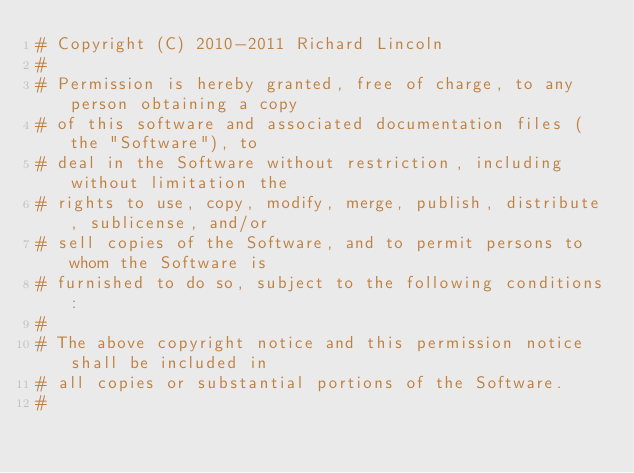Convert code to text. <code><loc_0><loc_0><loc_500><loc_500><_Python_># Copyright (C) 2010-2011 Richard Lincoln
#
# Permission is hereby granted, free of charge, to any person obtaining a copy
# of this software and associated documentation files (the "Software"), to
# deal in the Software without restriction, including without limitation the
# rights to use, copy, modify, merge, publish, distribute, sublicense, and/or
# sell copies of the Software, and to permit persons to whom the Software is
# furnished to do so, subject to the following conditions:
#
# The above copyright notice and this permission notice shall be included in
# all copies or substantial portions of the Software.
#</code> 